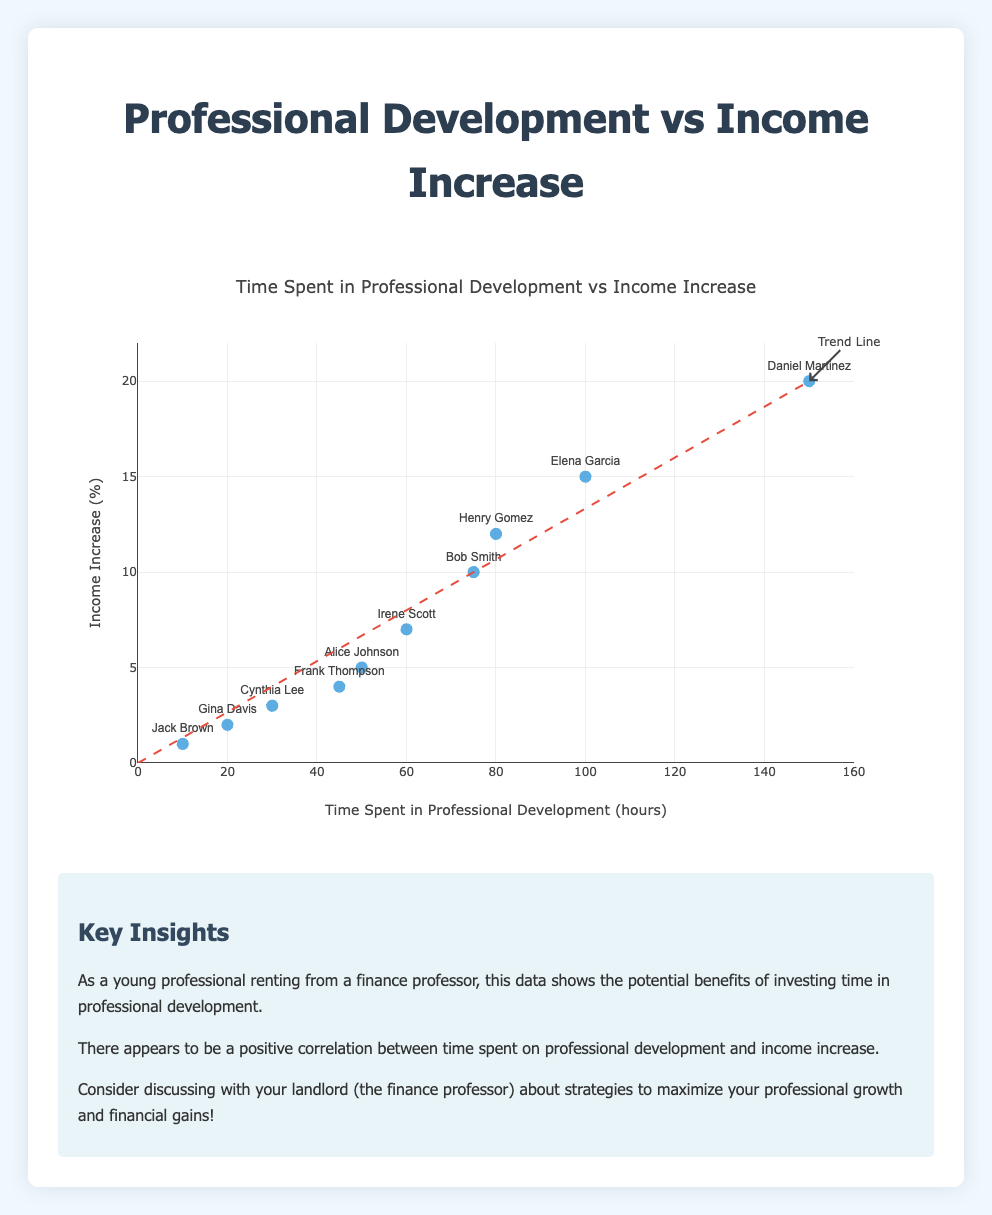What's the title of the figure? The title is usually placed at the top of the chart or figure. In this case, the title reads "Time Spent in Professional Development vs Income Increase."
Answer: Time Spent in Professional Development vs Income Increase How many data points are there in the scatter plot? To determine the number of data points, count the total number of entries provided in the data which are individually represented in the scatter plot. There are 10 entries in the data provided.
Answer: 10 What color are the data markers in the scatter plot? The color of the data markers is visible in the scatter plot. In this case, they are described to be 'color: #3498db', which is a shade of blue.
Answer: Blue Which individual spent the most time in professional development hours? Sort the data entries based on the 'time_spent_in_professional_development_hours'. The highest value is 150 hours spent by Daniel Martinez.
Answer: Daniel Martinez What is the income increase percentage for someone who spent 100 hours in professional development? Locate the data entry with 100 hours spent in professional development. The corresponding income increase percentage for Elena Garcia is 15%.
Answer: 15% What is the average income increase percentage for the employees? Sum the income increase percentages and divide by the number of data points. (5+10+3+20+15+4+2+12+7+1) = 79, average = 79 / 10 = 7.9%
Answer: 7.9% Who had an income increase percentage equal to double the professional development hours spent by Jack Brown? Jack Brown spent 10 hours, so double that is 20%. Check data entries for 20%, which is Daniel Martinez with 150 hours in professional development.
Answer: Daniel Martinez Which individual spent the least time in professional development, and what was their income increase percentage? Identify the minimum value in the 'time_spent_in_professional_development_hours', which is Jack Brown with 10 hours and an income increase percentage of 1%.
Answer: Jack Brown, 1% How does the trend line relate to the data points? The trend line shows the general direction of the data points, indicating a positive correlation between hours spent on professional development and income increase. Most data points align or are near this trend line.
Answer: Positive correlation Does Cynthia Lee's income increase equate to her percentage of time spent in professional development? Cynthia Lee spent 30 hours in professional development and had an income increase of 3%, which is 1/10th of the time spent.
Answer: No 